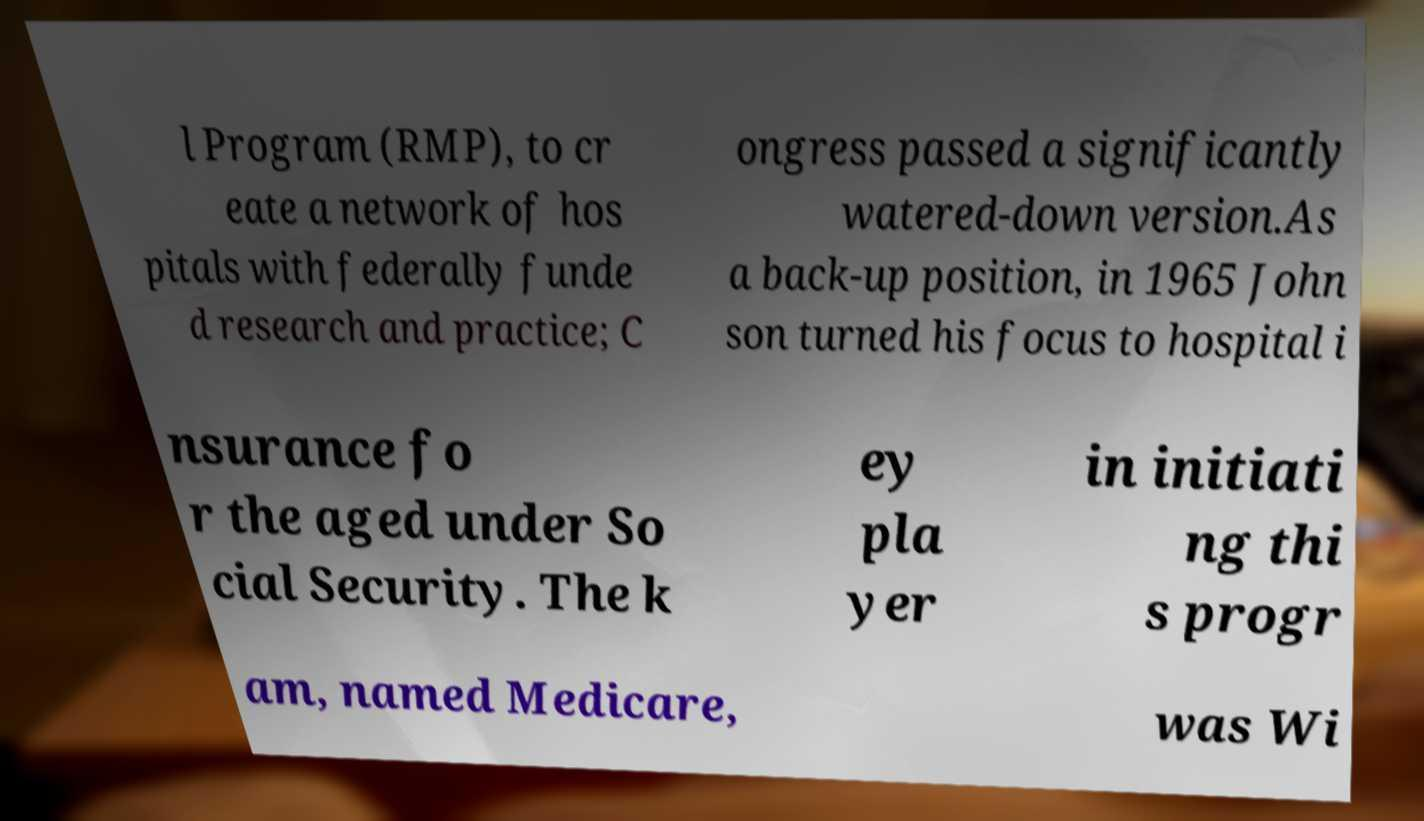For documentation purposes, I need the text within this image transcribed. Could you provide that? l Program (RMP), to cr eate a network of hos pitals with federally funde d research and practice; C ongress passed a significantly watered-down version.As a back-up position, in 1965 John son turned his focus to hospital i nsurance fo r the aged under So cial Security. The k ey pla yer in initiati ng thi s progr am, named Medicare, was Wi 